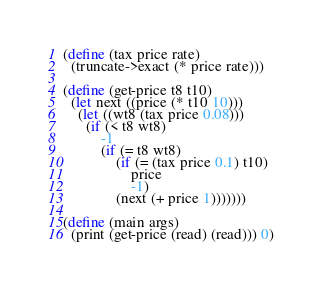Convert code to text. <code><loc_0><loc_0><loc_500><loc_500><_Scheme_>(define (tax price rate)
  (truncate->exact (* price rate)))

(define (get-price t8 t10)
  (let next ((price (* t10 10)))
    (let ((wt8 (tax price 0.08)))
      (if (< t8 wt8)
          -1
          (if (= t8 wt8)
              (if (= (tax price 0.1) t10)
                  price
                  -1)
              (next (+ price 1)))))))

(define (main args)
  (print (get-price (read) (read))) 0)</code> 